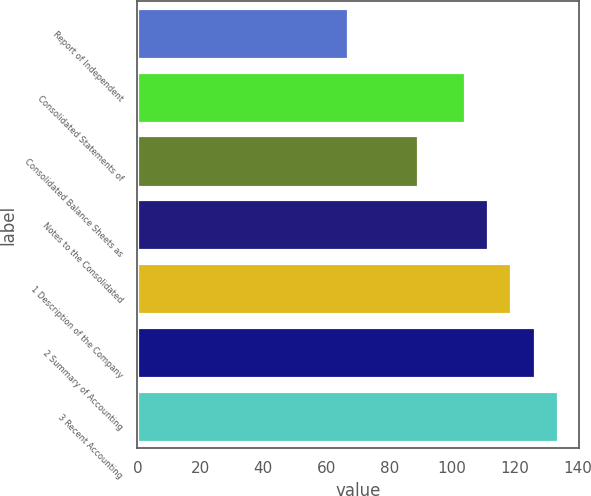Convert chart to OTSL. <chart><loc_0><loc_0><loc_500><loc_500><bar_chart><fcel>Report of Independent<fcel>Consolidated Statements of<fcel>Consolidated Balance Sheets as<fcel>Notes to the Consolidated<fcel>1 Description of the Company<fcel>2 Summary of Accounting<fcel>3 Recent Accounting<nl><fcel>67<fcel>104<fcel>89.2<fcel>111.4<fcel>118.8<fcel>126.2<fcel>133.6<nl></chart> 